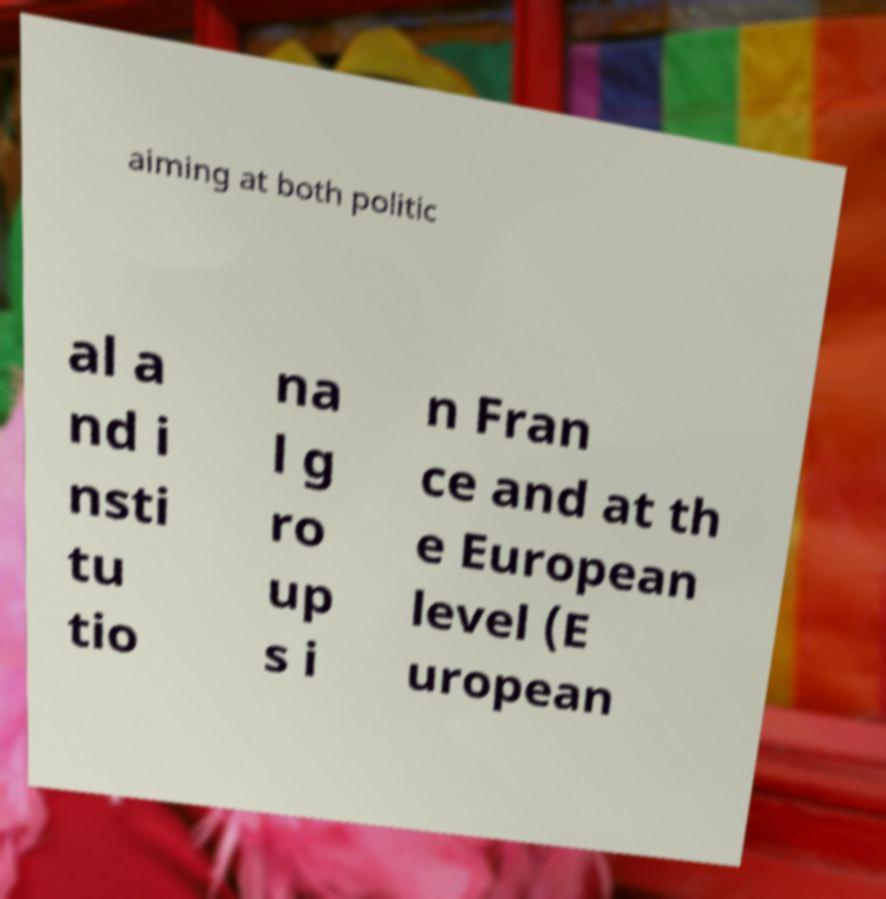I need the written content from this picture converted into text. Can you do that? aiming at both politic al a nd i nsti tu tio na l g ro up s i n Fran ce and at th e European level (E uropean 